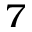<formula> <loc_0><loc_0><loc_500><loc_500>_ { 7 }</formula> 